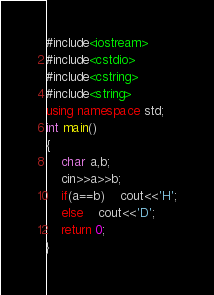Convert code to text. <code><loc_0><loc_0><loc_500><loc_500><_C++_>#include<iostream>
#include<cstdio>
#include<cstring>
#include<string>
using namespace std;
int main()
{
	char a,b;
	cin>>a>>b;
	if(a==b)	cout<<'H';
	else	cout<<'D';
	return 0;
}</code> 